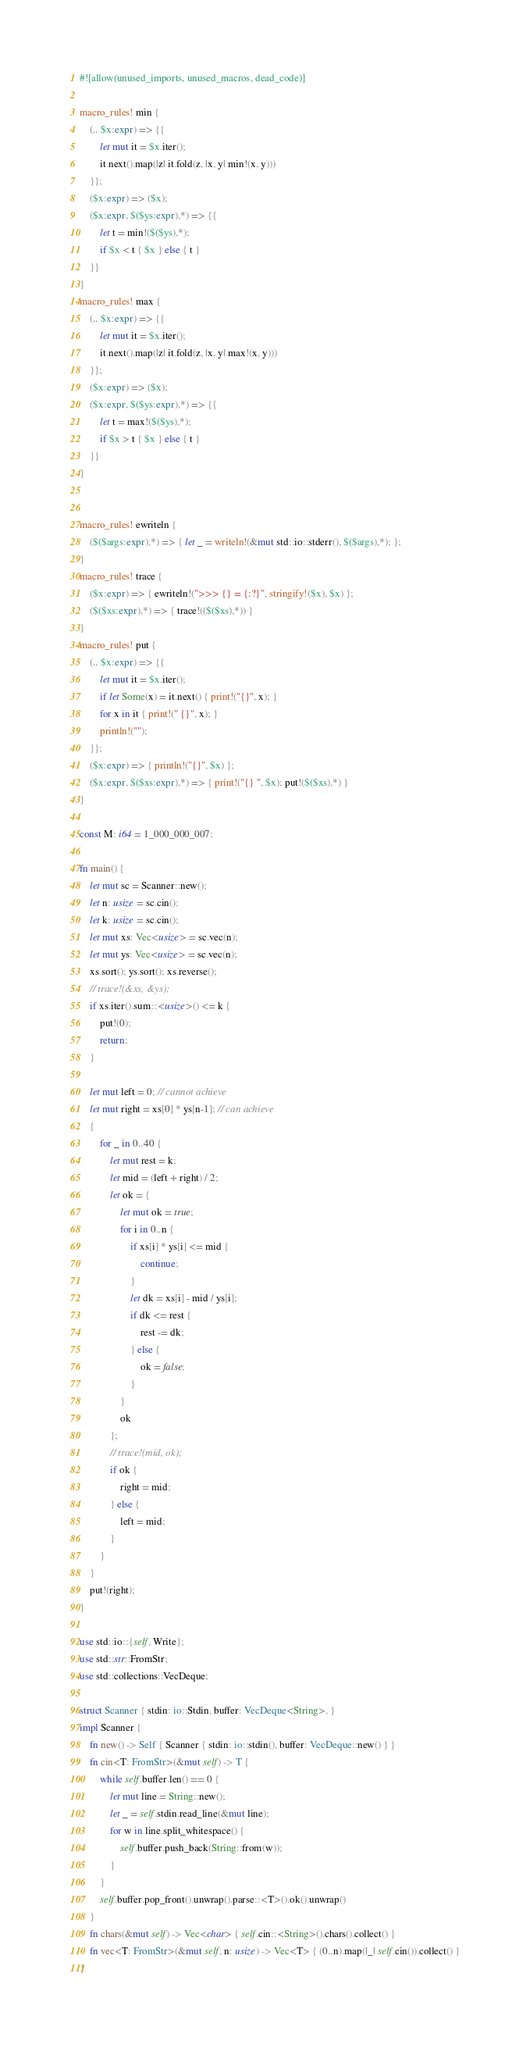Convert code to text. <code><loc_0><loc_0><loc_500><loc_500><_Rust_>#![allow(unused_imports, unused_macros, dead_code)]

macro_rules! min {
    (.. $x:expr) => {{
        let mut it = $x.iter();
        it.next().map(|z| it.fold(z, |x, y| min!(x, y)))
    }};
    ($x:expr) => ($x);
    ($x:expr, $($ys:expr),*) => {{
        let t = min!($($ys),*);
        if $x < t { $x } else { t }
    }}
}
macro_rules! max {
    (.. $x:expr) => {{
        let mut it = $x.iter();
        it.next().map(|z| it.fold(z, |x, y| max!(x, y)))
    }};
    ($x:expr) => ($x);
    ($x:expr, $($ys:expr),*) => {{
        let t = max!($($ys),*);
        if $x > t { $x } else { t }
    }}
}


macro_rules! ewriteln {
    ($($args:expr),*) => { let _ = writeln!(&mut std::io::stderr(), $($args),*); };
}
macro_rules! trace {
    ($x:expr) => { ewriteln!(">>> {} = {:?}", stringify!($x), $x) };
    ($($xs:expr),*) => { trace!(($($xs),*)) }
}
macro_rules! put {
    (.. $x:expr) => {{
        let mut it = $x.iter();
        if let Some(x) = it.next() { print!("{}", x); }
        for x in it { print!(" {}", x); }
        println!("");
    }};
    ($x:expr) => { println!("{}", $x) };
    ($x:expr, $($xs:expr),*) => { print!("{} ", $x); put!($($xs),*) }
}

const M: i64 = 1_000_000_007;

fn main() {
    let mut sc = Scanner::new();
    let n: usize = sc.cin();
    let k: usize = sc.cin();
    let mut xs: Vec<usize> = sc.vec(n);
    let mut ys: Vec<usize> = sc.vec(n);
    xs.sort(); ys.sort(); xs.reverse();
    // trace!(&xs, &ys);
    if xs.iter().sum::<usize>() <= k {
        put!(0);
        return;
    }

    let mut left = 0; // cannot achieve
    let mut right = xs[0] * ys[n-1]; // can achieve
    {
        for _ in 0..40 {
            let mut rest = k;
            let mid = (left + right) / 2;
            let ok = {
                let mut ok = true;
                for i in 0..n {
                    if xs[i] * ys[i] <= mid {
                        continue;
                    }
                    let dk = xs[i] - mid / ys[i];
                    if dk <= rest {
                        rest -= dk;
                    } else {
                        ok = false;
                    }
                }
                ok
            };
            // trace!(mid, ok);
            if ok {
                right = mid;
            } else {
                left = mid;
            }
        }
    }
    put!(right);
}

use std::io::{self, Write};
use std::str::FromStr;
use std::collections::VecDeque;

struct Scanner { stdin: io::Stdin, buffer: VecDeque<String>, }
impl Scanner {
    fn new() -> Self { Scanner { stdin: io::stdin(), buffer: VecDeque::new() } }
    fn cin<T: FromStr>(&mut self) -> T {
        while self.buffer.len() == 0 {
            let mut line = String::new();
            let _ = self.stdin.read_line(&mut line);
            for w in line.split_whitespace() {
                self.buffer.push_back(String::from(w));
            }
        }
        self.buffer.pop_front().unwrap().parse::<T>().ok().unwrap()
    }
    fn chars(&mut self) -> Vec<char> { self.cin::<String>().chars().collect() }
    fn vec<T: FromStr>(&mut self, n: usize) -> Vec<T> { (0..n).map(|_| self.cin()).collect() }
}
</code> 